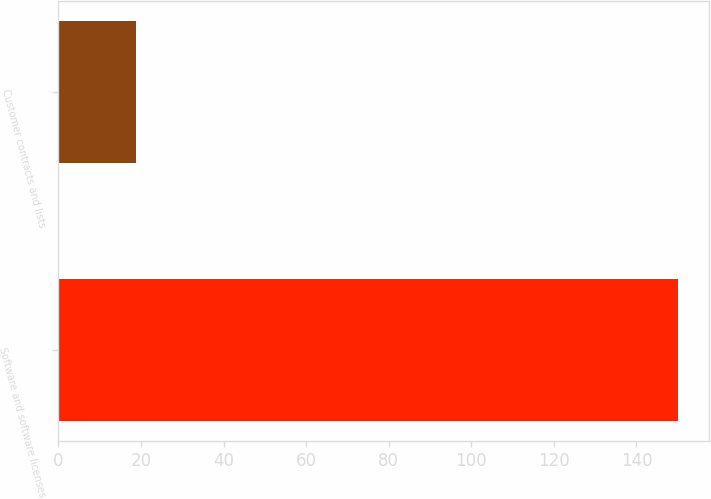Convert chart to OTSL. <chart><loc_0><loc_0><loc_500><loc_500><bar_chart><fcel>Software and software licenses<fcel>Customer contracts and lists<nl><fcel>150<fcel>18.8<nl></chart> 